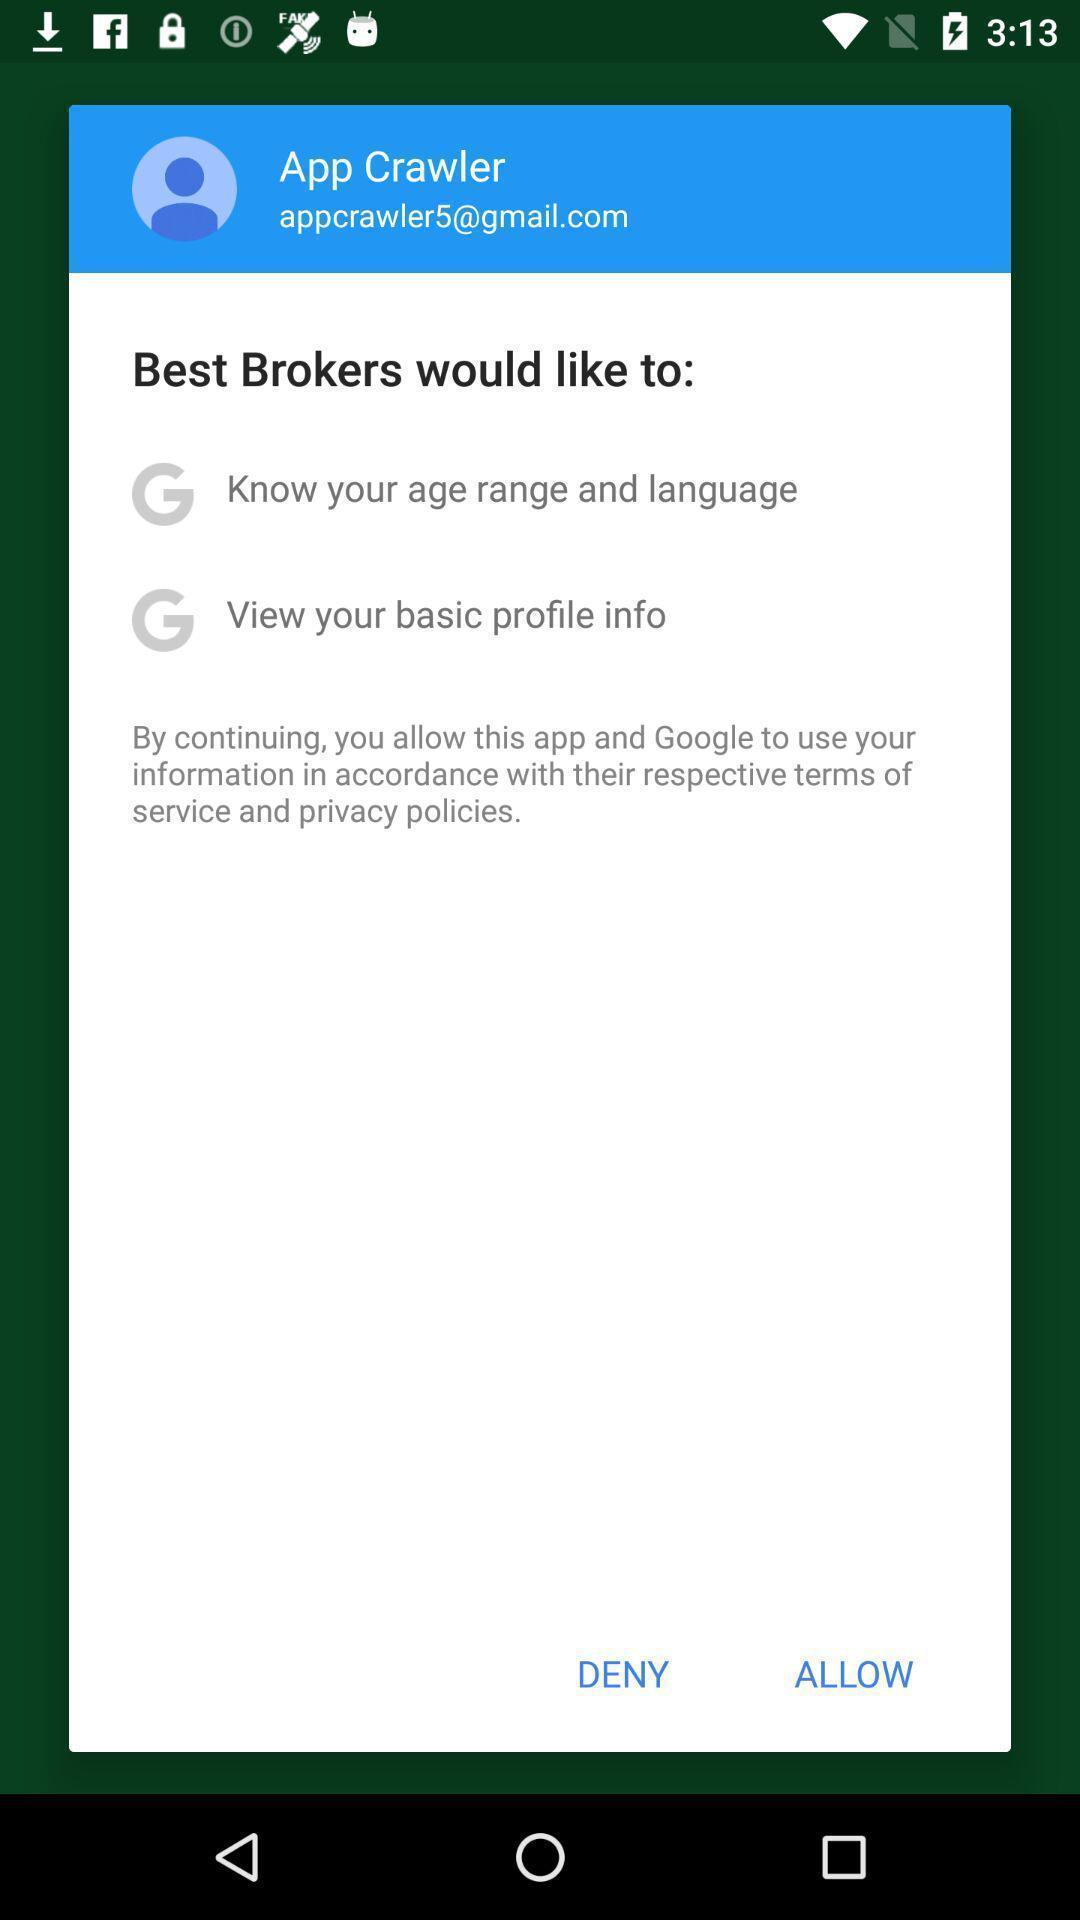Tell me what you see in this picture. Popup page for allowing terms and conditions. 